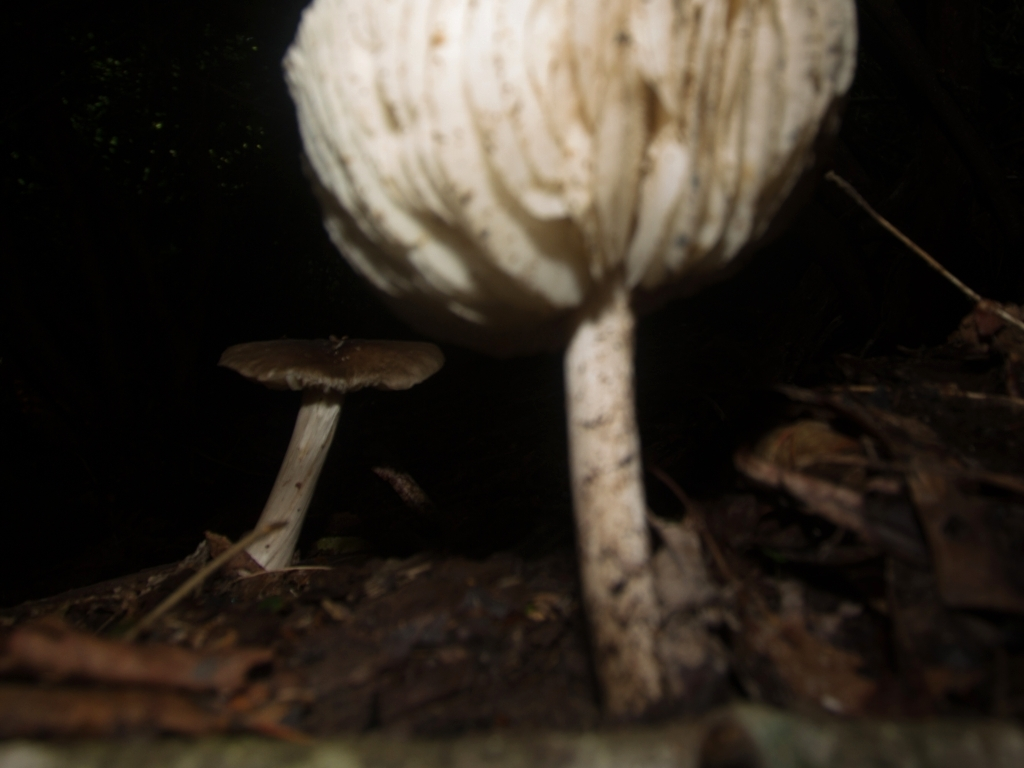Can you describe the environment where these mushrooms are growing? These mushrooms appear to be growing in a dark, possibly forested area with ample organic material on the ground, such as twigs and fallen leaves, which is typical for fungi since they thrive in moist, nutrient-rich environments. 